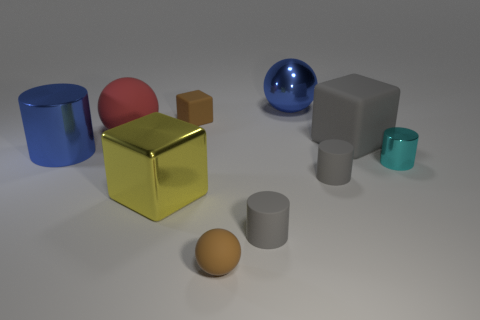Do the cylinder that is on the left side of the yellow object and the big shiny object that is in front of the small cyan object have the same color?
Offer a very short reply. No. Is there anything else that is made of the same material as the brown ball?
Give a very brief answer. Yes. The brown matte thing that is the same shape as the big gray rubber thing is what size?
Ensure brevity in your answer.  Small. Are there more things that are to the right of the big yellow thing than big purple cylinders?
Provide a short and direct response. Yes. Is the small gray cylinder in front of the yellow thing made of the same material as the small sphere?
Your answer should be very brief. Yes. What is the size of the brown rubber thing that is behind the large cube right of the brown rubber object behind the big matte sphere?
Provide a succinct answer. Small. What size is the red ball that is the same material as the gray cube?
Provide a succinct answer. Large. What is the color of the metal object that is both on the right side of the yellow metal object and behind the small cyan shiny object?
Give a very brief answer. Blue. Does the big metallic thing right of the tiny brown rubber ball have the same shape as the blue metallic object in front of the big rubber block?
Provide a succinct answer. No. There is a blue object that is on the left side of the big yellow block; what is it made of?
Ensure brevity in your answer.  Metal. 